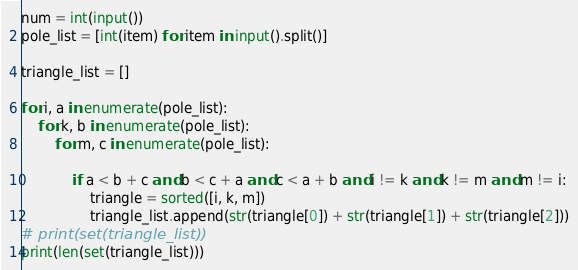Convert code to text. <code><loc_0><loc_0><loc_500><loc_500><_Python_>num = int(input())
pole_list = [int(item) for item in input().split()]

triangle_list = []

for i, a in enumerate(pole_list):
    for k, b in enumerate(pole_list):
        for m, c in enumerate(pole_list):

            if a < b + c and b < c + a and c < a + b and i != k and k != m and m != i:
                triangle = sorted([i, k, m])
                triangle_list.append(str(triangle[0]) + str(triangle[1]) + str(triangle[2]))
# print(set(triangle_list))
print(len(set(triangle_list)))
</code> 